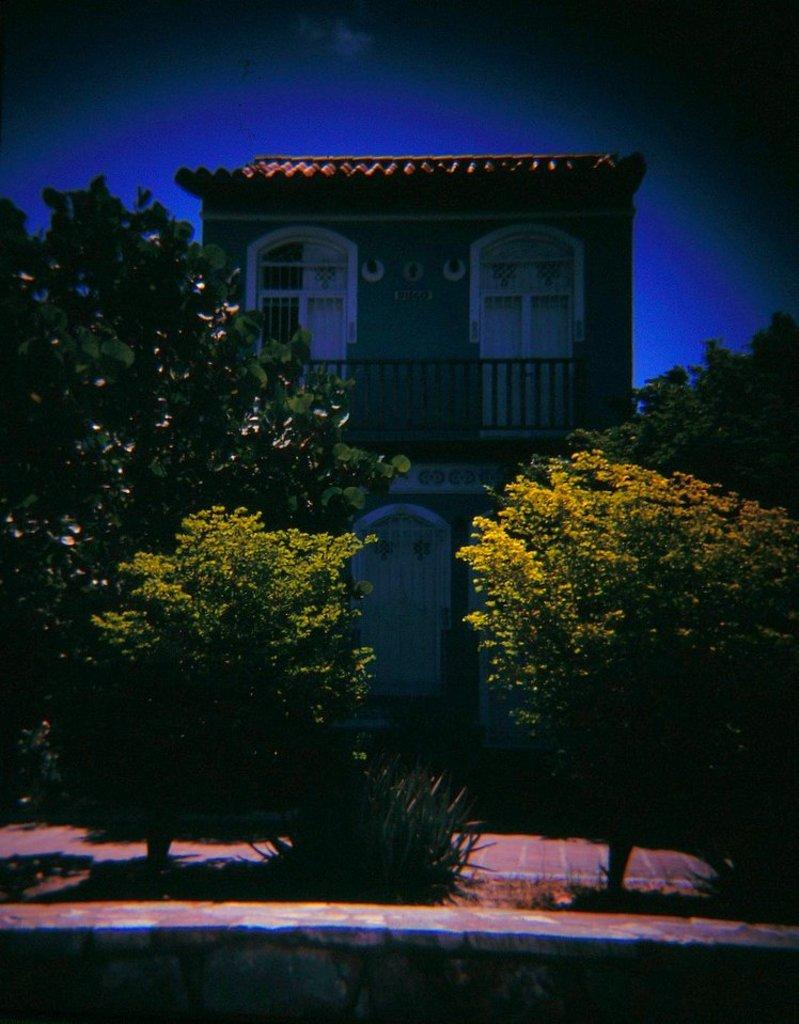What type of vegetation can be seen in the image? There are plants and trees in the image. What structure is visible in the background of the image? There is a house in the background of the image. What feature can be observed on the house? The house has a railing. What is visible in the sky in the background of the image? The sky is visible in the background of the image. Can you tell me how many straws are being used by the giraffe in the image? There is no giraffe or straw present in the image. 